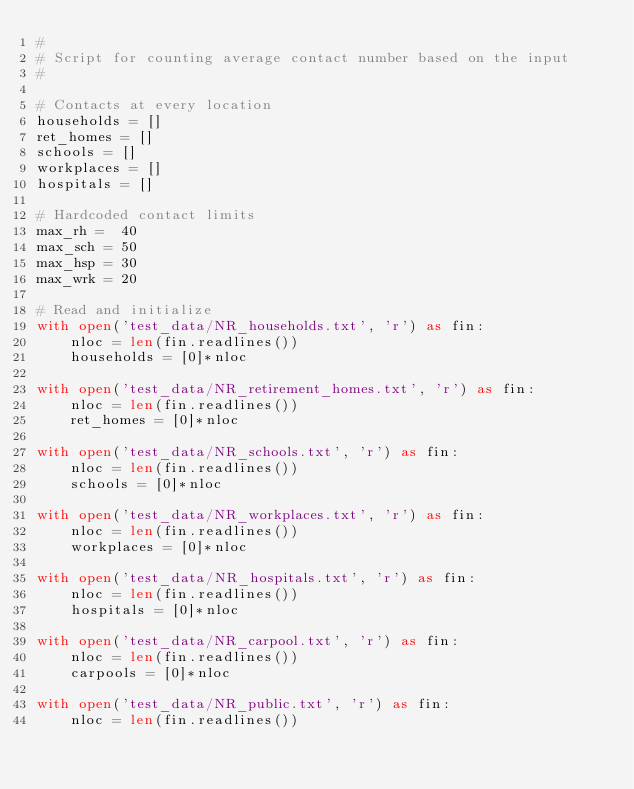Convert code to text. <code><loc_0><loc_0><loc_500><loc_500><_Python_>#
# Script for counting average contact number based on the input
#

# Contacts at every location 
households = []
ret_homes = []
schools = []
workplaces = []
hospitals = []

# Hardcoded contact limits
max_rh =  40
max_sch = 50
max_hsp = 30
max_wrk = 20

# Read and initialize
with open('test_data/NR_households.txt', 'r') as fin:
	nloc = len(fin.readlines())
	households = [0]*nloc

with open('test_data/NR_retirement_homes.txt', 'r') as fin:
	nloc = len(fin.readlines())
	ret_homes = [0]*nloc

with open('test_data/NR_schools.txt', 'r') as fin:
	nloc = len(fin.readlines())
	schools = [0]*nloc

with open('test_data/NR_workplaces.txt', 'r') as fin:
	nloc = len(fin.readlines())
	workplaces = [0]*nloc

with open('test_data/NR_hospitals.txt', 'r') as fin:
	nloc = len(fin.readlines())
	hospitals = [0]*nloc

with open('test_data/NR_carpool.txt', 'r') as fin:
	nloc = len(fin.readlines())
	carpools = [0]*nloc

with open('test_data/NR_public.txt', 'r') as fin:
	nloc = len(fin.readlines())</code> 